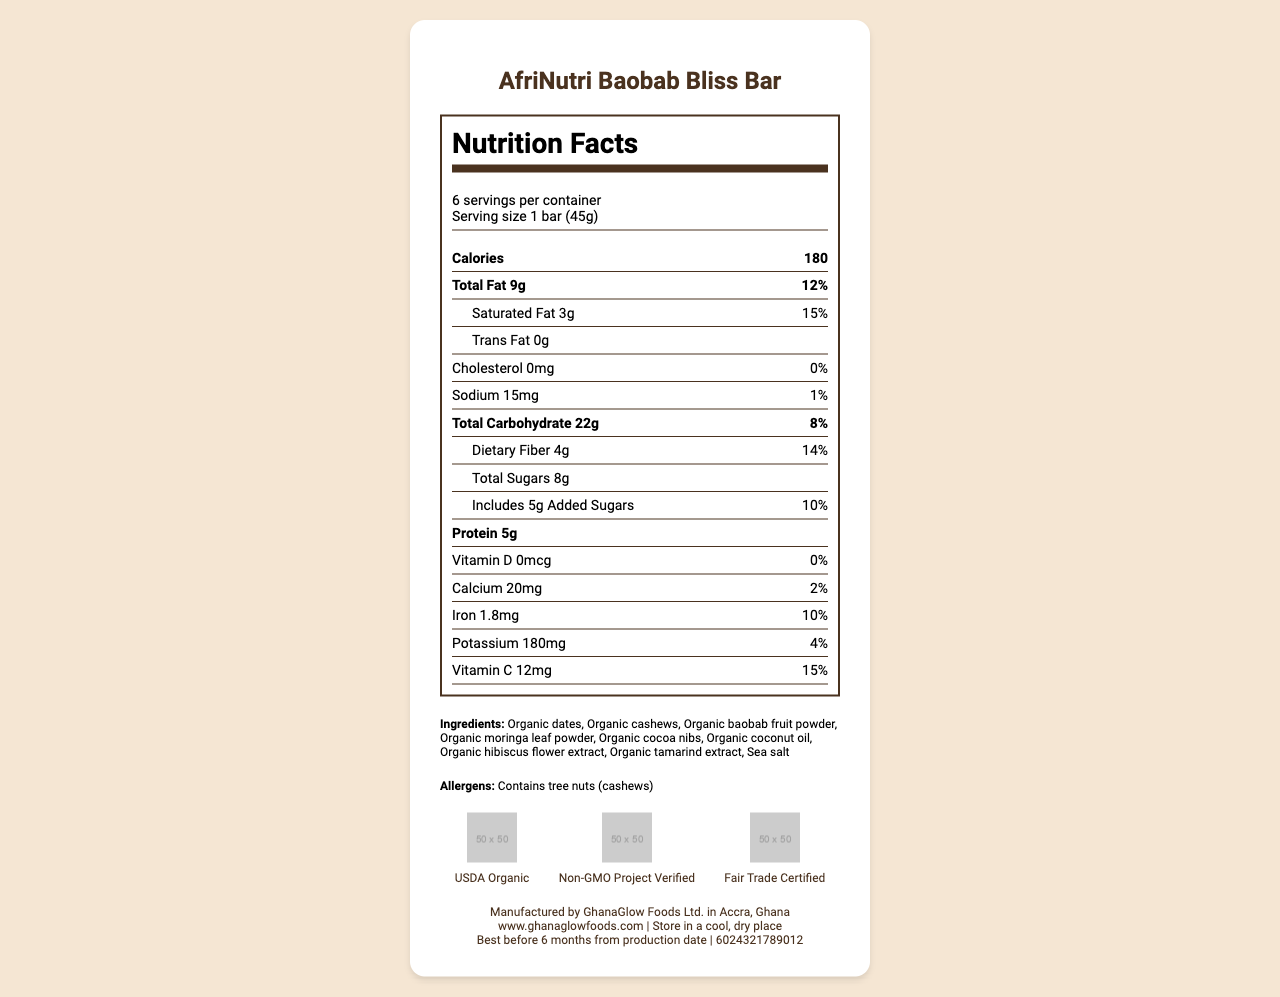What is the serving size of the AfriNutri Baobab Bliss Bar? The serving size is clearly mentioned as "1 bar (45g)" in the nutrition label.
Answer: 1 bar (45g) How many calories are there in one serving of the AfriNutri Baobab Bliss Bar? The nutrition label lists the calories as 180 per serving.
Answer: 180 What traditional African ingredients are included in the AfriNutri Baobab Bliss Bar? These ingredients are mentioned in the "Ingredients" section in the document.
Answer: Organic baobab fruit powder, Organic moringa leaf powder, Organic hibiscus flower extract, Organic tamarind extract How much protein does one bar contain? The nutrition label specifies that there are 5 grams of protein per serving.
Answer: 5g What is the percentage of daily value for dietary fiber in one serving? The daily value percentage for dietary fiber is listed as 14%.
Answer: 14% Which of the following certifications does the product have? A. USDA Organic B. Non-GMO Project Verified C. Fair Trade Certified D. All of the above The product has all three certifications listed in the "certifications" section of the document.
Answer: D. All of the above What is the total amount of sugars in one serving? A. 4g B. 8g C. 10g D. 12g The total sugars are listed as 8 grams in the nutrition label.
Answer: B. 8g Does the AfriNutri Baobab Bliss Bar contain any cholesterol? The cholesterol amount is listed as 0mg, which means it contains no cholesterol.
Answer: No Is the AfriNutri Baobab Bliss Bar suitable for someone with a cashew allergy? The ingredients list contains organic cashews, and the allergens section explicitly mentions "Contains tree nuts (cashews)".
Answer: No Please summarize the main idea of the document. The document is a comprehensive nutrition label for the AfriNutri Baobab Bliss Bar, covering its nutritional content, ingredients, allergens, certifications, and additional product information.
Answer: The document provides detailed nutrition facts and ingredient information for the AfriNutri Baobab Bliss Bar, a locally-produced organic snack bar with traditional African ingredients. It includes nutritional values per serving, certifies various health and sourcing standards, lists potential allergens, and provides storage and manufacturing details. What are the main vitamins mentioned in the label? These vitamins are listed in the nutrition label detailing their amounts and daily values.
Answer: Vitamin D, Calcium, Iron, Potassium, Vitamin C Where is the AfriNutri Baobab Bliss Bar produced? The manufacturing location is specified as Accra, Ghana in the document.
Answer: Accra, Ghana What is the total fat percentage of the daily value in one serving? The total fat percentage of the daily value is listed as 12% on the nutrition label.
Answer: 12% How long can the AfriNutri Baobab Bliss Bar be stored before it expires? The expiration date section specifies the storage duration as "Best before 6 months from production date".
Answer: Best before 6 months from production date What is the exact expiration date of the AfriNutri Baobab Bliss Bar? The label only indicates that it is best before 6 months from the production date, but the exact production date is not provided in the document.
Answer: Cannot be determined 